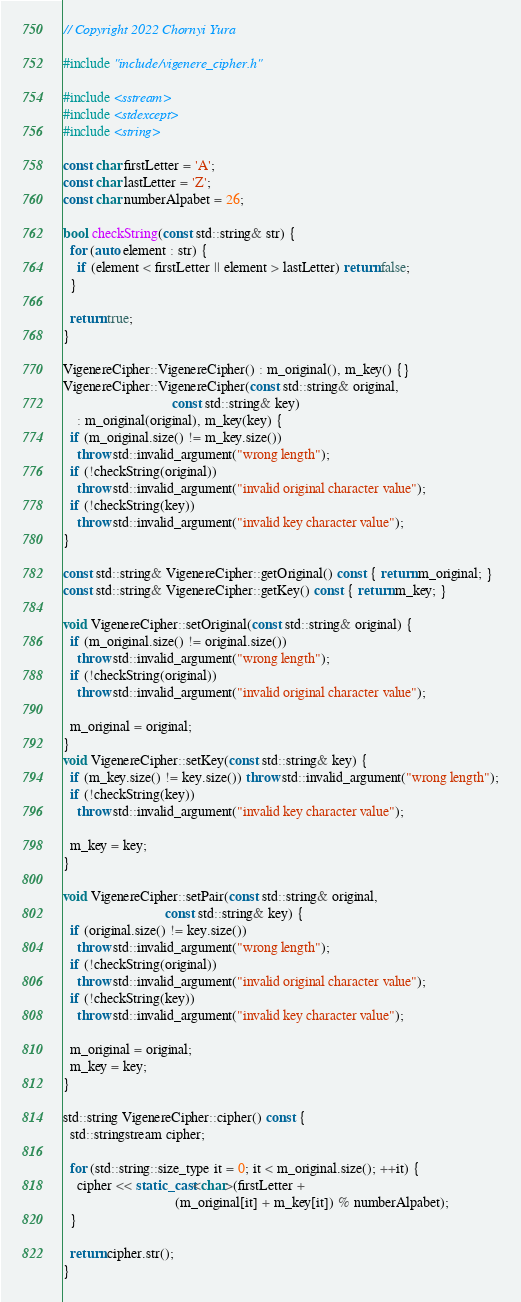Convert code to text. <code><loc_0><loc_0><loc_500><loc_500><_C++_>// Copyright 2022 Chornyi Yura

#include "include/vigenere_cipher.h"

#include <sstream>
#include <stdexcept>
#include <string>

const char firstLetter = 'A';
const char lastLetter = 'Z';
const char numberAlpabet = 26;

bool checkString(const std::string& str) {
  for (auto element : str) {
    if (element < firstLetter || element > lastLetter) return false;
  }

  return true;
}

VigenereCipher::VigenereCipher() : m_original(), m_key() {}
VigenereCipher::VigenereCipher(const std::string& original,
                               const std::string& key)
    : m_original(original), m_key(key) {
  if (m_original.size() != m_key.size())
    throw std::invalid_argument("wrong length");
  if (!checkString(original))
    throw std::invalid_argument("invalid original character value");
  if (!checkString(key))
    throw std::invalid_argument("invalid key character value");
}

const std::string& VigenereCipher::getOriginal() const { return m_original; }
const std::string& VigenereCipher::getKey() const { return m_key; }

void VigenereCipher::setOriginal(const std::string& original) {
  if (m_original.size() != original.size())
    throw std::invalid_argument("wrong length");
  if (!checkString(original))
    throw std::invalid_argument("invalid original character value");

  m_original = original;
}
void VigenereCipher::setKey(const std::string& key) {
  if (m_key.size() != key.size()) throw std::invalid_argument("wrong length");
  if (!checkString(key))
    throw std::invalid_argument("invalid key character value");

  m_key = key;
}

void VigenereCipher::setPair(const std::string& original,
                             const std::string& key) {
  if (original.size() != key.size())
    throw std::invalid_argument("wrong length");
  if (!checkString(original))
    throw std::invalid_argument("invalid original character value");
  if (!checkString(key))
    throw std::invalid_argument("invalid key character value");

  m_original = original;
  m_key = key;
}

std::string VigenereCipher::cipher() const {
  std::stringstream cipher;

  for (std::string::size_type it = 0; it < m_original.size(); ++it) {
    cipher << static_cast<char>(firstLetter +
                                (m_original[it] + m_key[it]) % numberAlpabet);
  }

  return cipher.str();
}
</code> 